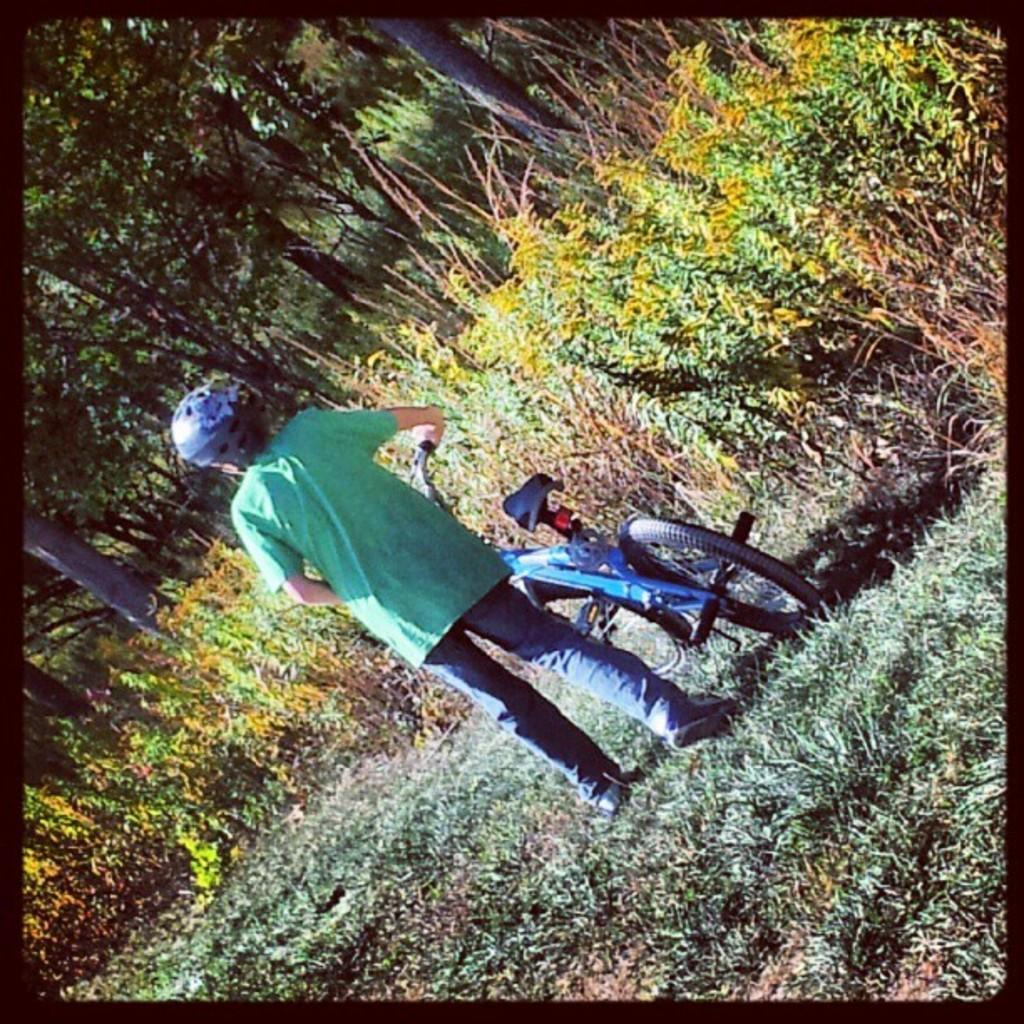Could you give a brief overview of what you see in this image? In the image we can see a child wearing clothes, shoes, helmet and the child is holding a bike handles. This is grass, plant and trees. 